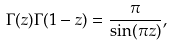<formula> <loc_0><loc_0><loc_500><loc_500>\Gamma ( z ) \Gamma ( 1 - z ) = \frac { \pi } { \sin ( \pi z ) } ,</formula> 